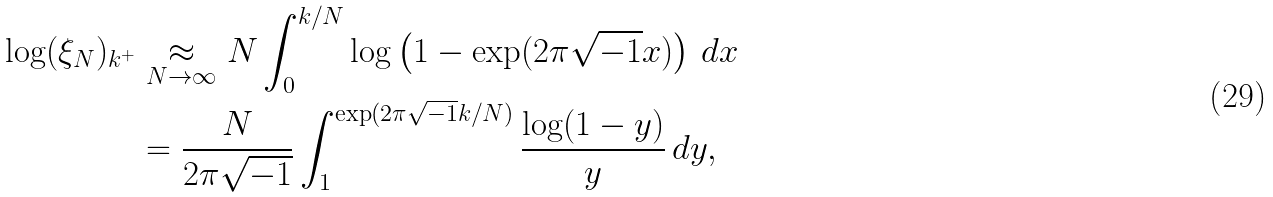<formula> <loc_0><loc_0><loc_500><loc_500>\log ( \xi _ { N } ) _ { k ^ { + } } & \underset { N \to \infty } { \approx } N \int _ { 0 } ^ { k / N } \log \left ( 1 - \exp ( 2 \pi \sqrt { - 1 } x ) \right ) \, d x \\ & = \frac { N } { 2 \pi \sqrt { - 1 } } \int _ { 1 } ^ { \exp ( 2 \pi \sqrt { - 1 } k / N ) } \frac { \log ( 1 - y ) } { y } \, d y ,</formula> 